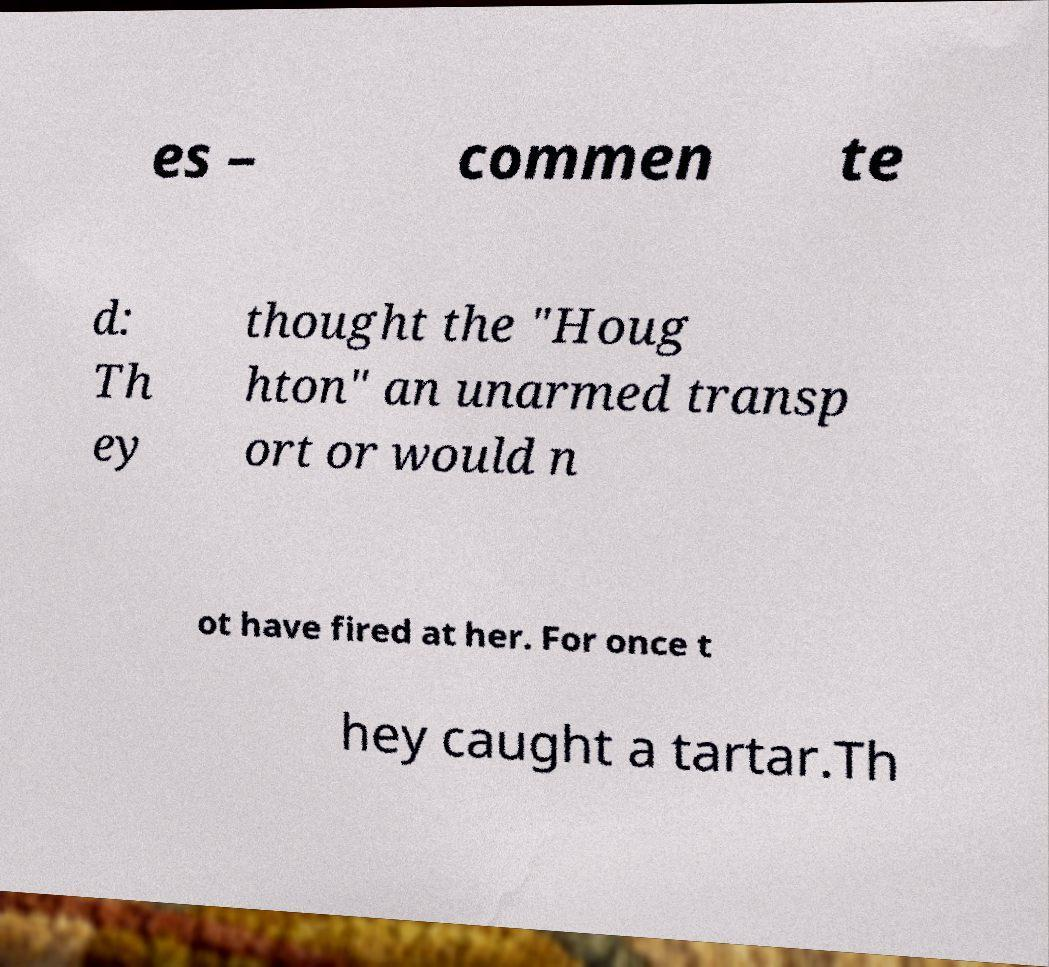Can you read and provide the text displayed in the image?This photo seems to have some interesting text. Can you extract and type it out for me? es – commen te d: Th ey thought the "Houg hton" an unarmed transp ort or would n ot have fired at her. For once t hey caught a tartar.Th 